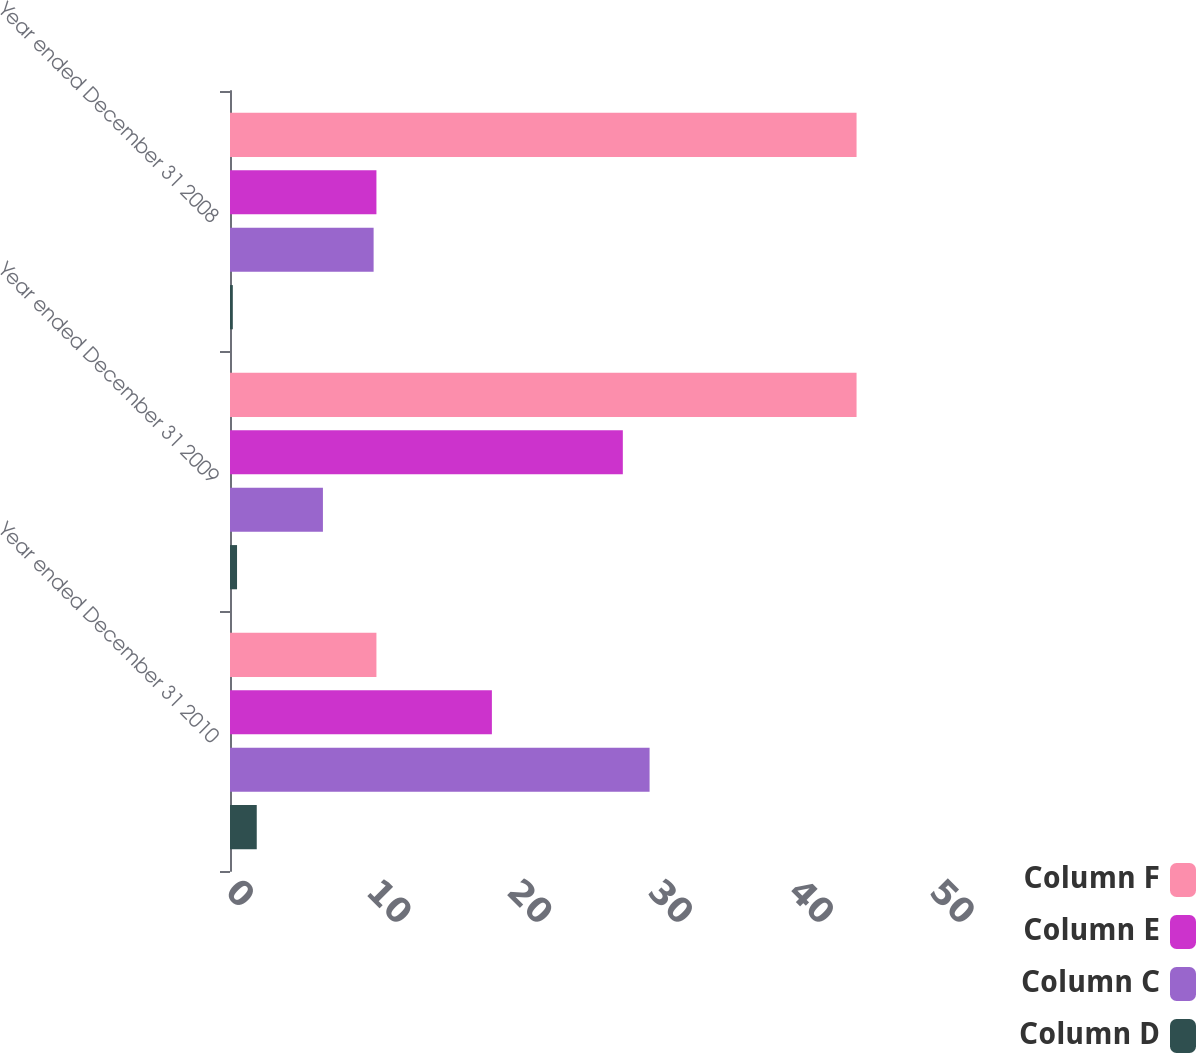Convert chart. <chart><loc_0><loc_0><loc_500><loc_500><stacked_bar_chart><ecel><fcel>Year ended December 31 2010<fcel>Year ended December 31 2009<fcel>Year ended December 31 2008<nl><fcel>Column F<fcel>10.4<fcel>44.5<fcel>44.5<nl><fcel>Column E<fcel>18.6<fcel>27.9<fcel>10.4<nl><fcel>Column C<fcel>29.8<fcel>6.6<fcel>10.2<nl><fcel>Column D<fcel>1.9<fcel>0.5<fcel>0.2<nl></chart> 